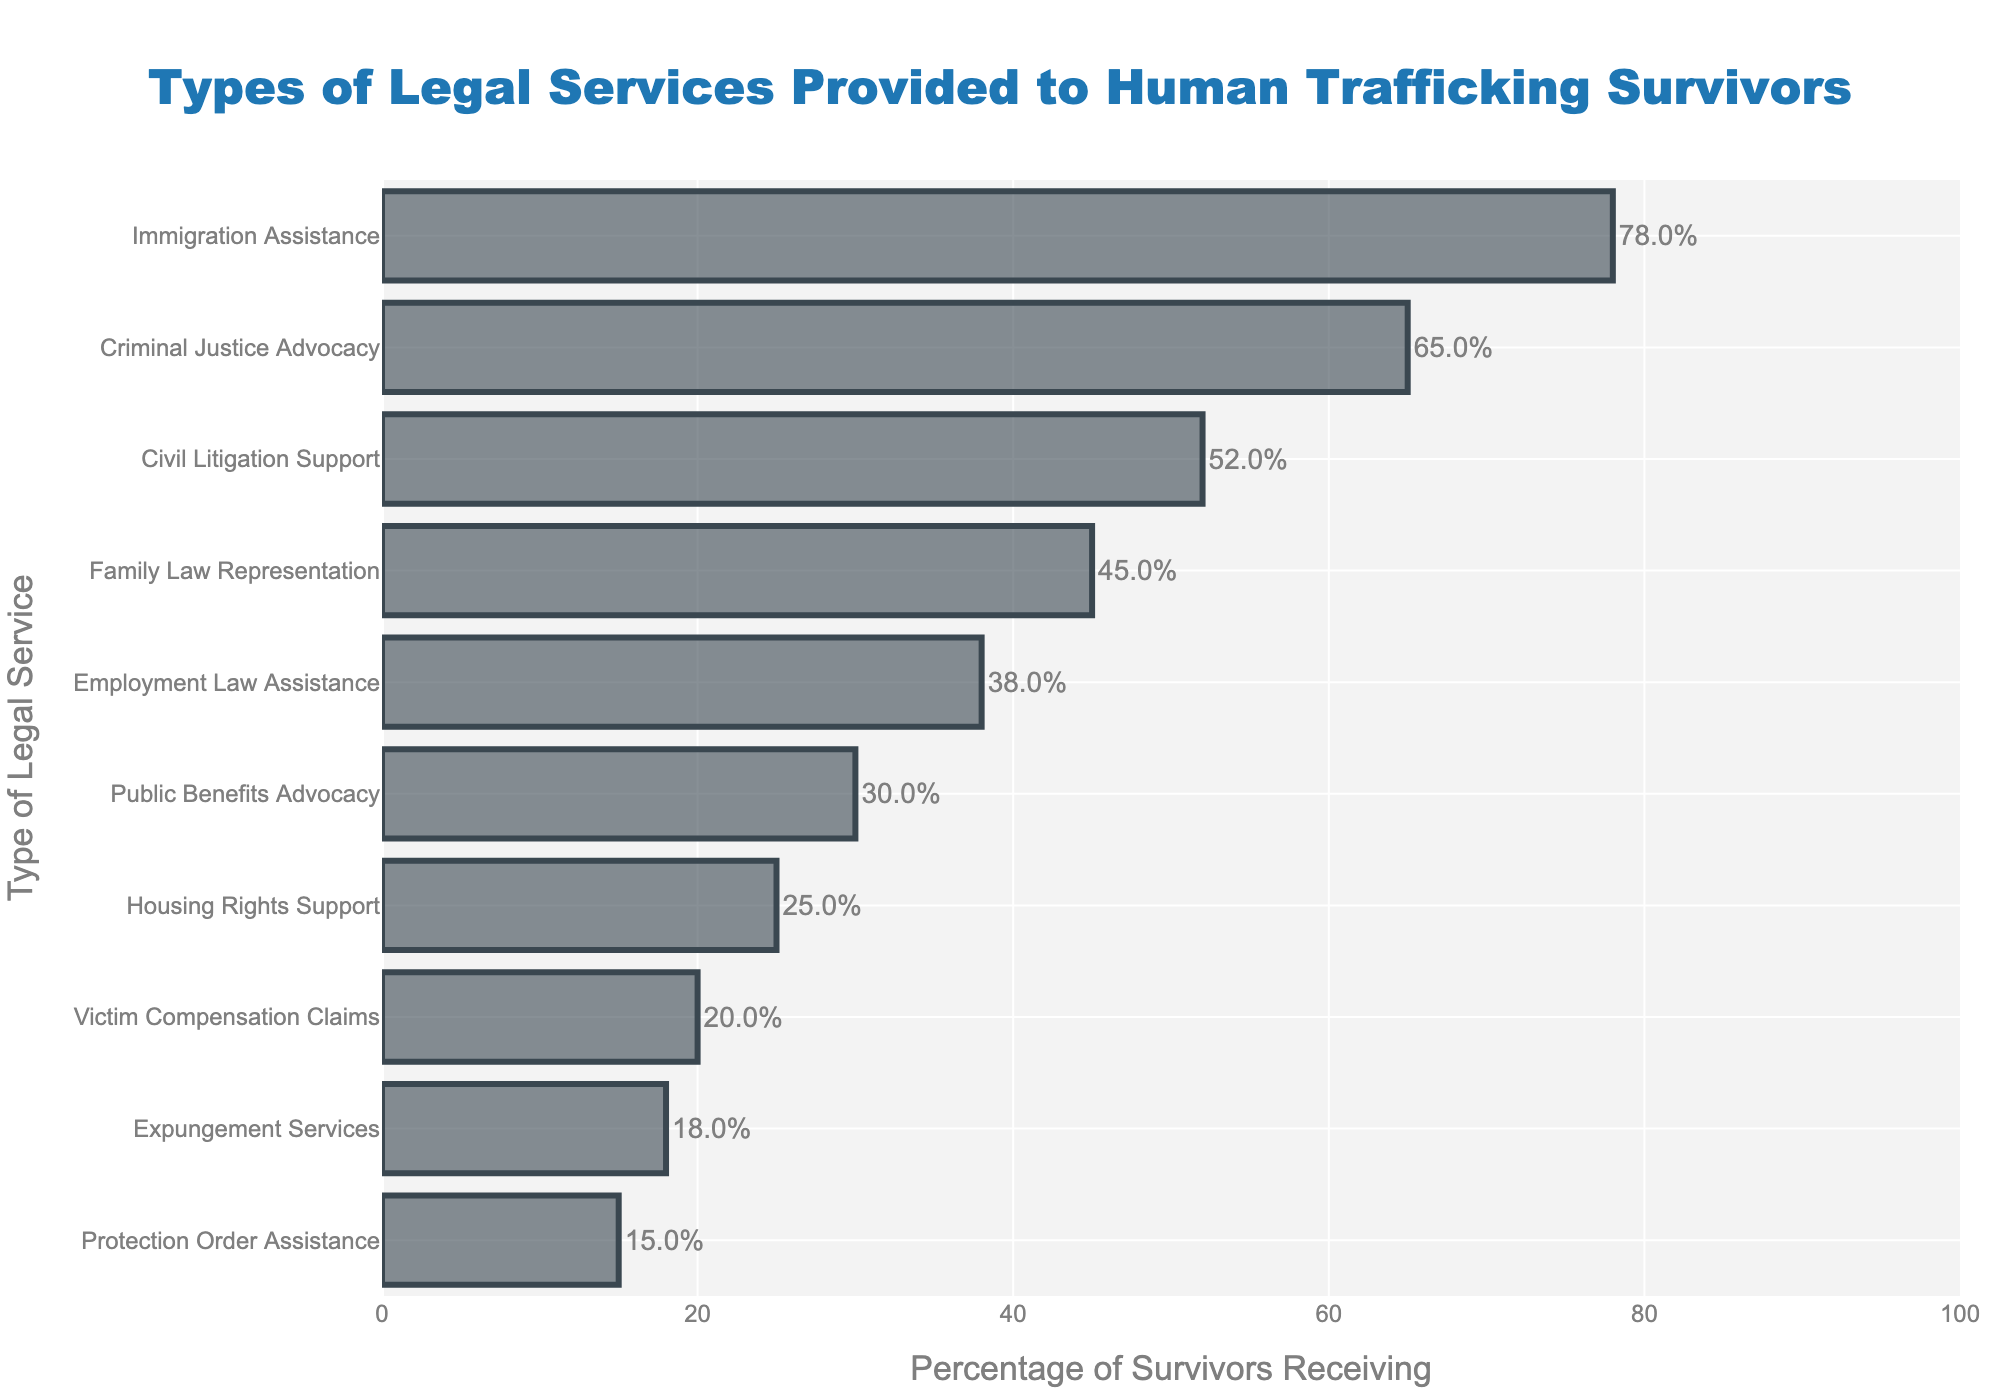what type of legal service has the highest percentage of survivors receiving assistance? The bar chart shows that the highest percentage bar is for Immigration Assistance.
Answer: Immigration Assistance which legal service is more common: civil litigation support or family law representation? By comparing the bars for Civil Litigation Support and Family Law Representation, we see that Civil Litigation Support has a higher percentage, 52% compared to 45%.
Answer: Civil Litigation Support what is the combined percentage of survivors receiving employment law assistance and housing rights support? The bar chart shows that Employment Law Assistance is 38% and Housing Rights Support is 25%. Adding them together: 38% + 25% = 63%.
Answer: 63% which type of legal service is less common: victim compensation claims or expungement services? By comparing the respective bars, we see that Victim Compensation Claims has a lower percentage (20%) compared to Expungement Services (18%).
Answer: Expungement Services what is the difference in percentage between criminal justice advocacy and public benefits advocacy? The chart shows Criminal Justice Advocacy at 65% and Public Benefits Advocacy at 30%. The difference is 65% - 30% = 35%.
Answer: 35% how many types of legal services have a percentage of survivors receiving assistance greater than 50%? The chart shows that Immigration Assistance (78%), Criminal Justice Advocacy (65%), and Civil Litigation Support (52%) have percentages above 50%. That makes a total of 3 services.
Answer: 3 is it true that protection order assistance is the least common type of legal service? The chart shows that Protection Order Assistance has the smallest percentage (15%) among all the services listed.
Answer: True what is the median percentage value of all the provided legal services? To find the median, list the percentages in ascending order (15%, 18%, 20%, 25%, 30%, 38%, 45%, 52%, 65%, 78%) and find the middle value. For an even number of entries, the median is the average of the 5th and 6th values: (30% + 38%) / 2 = 34%.
Answer: 34% which type of legal service has a percentage closest to the average percentage of all services provided? Calculate the average percentage first: (78% + 65% + 52% + 45% + 38% + 30% + 25% + 20% + 18% + 15%) / 10 = 38.6%. The closest value to 38.6% is Employment Law Assistance at 38%.
Answer: Employment Law Assistance what is the combined percentage of the three least provided legal services? The three least provided legal services are Protection Order Assistance (15%), Expungement Services (18%), and Victim Compensation Claims (20%). Adding them together: 15% + 18% + 20% = 53%.
Answer: 53% 